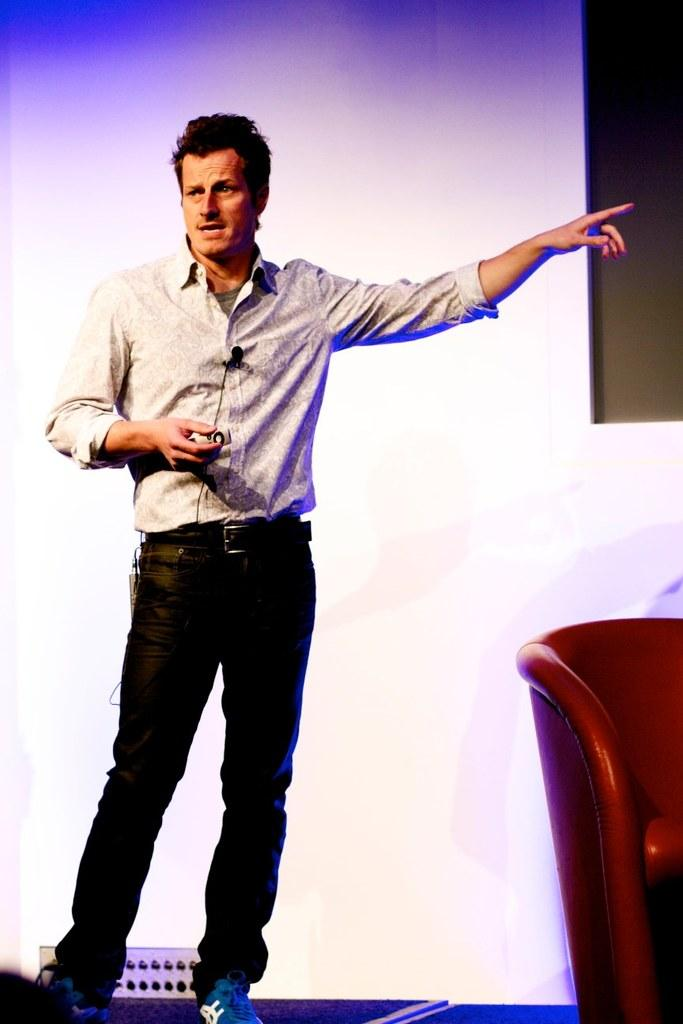What is the main subject of the image? There is a man in the image. What is the man doing in the image? The man is standing, talking, and pointing his finger. What is located behind the man? There is a chair behind the man. What can be seen in the background of the image? There is a screen visible in the background. What type of statement is the man making in the image? There is no indication of the content of the man's statement in the image, so it cannot be determined. What color is the yarn used to make the chair in the image? There is no yarn or chair made of yarn present in the image. 